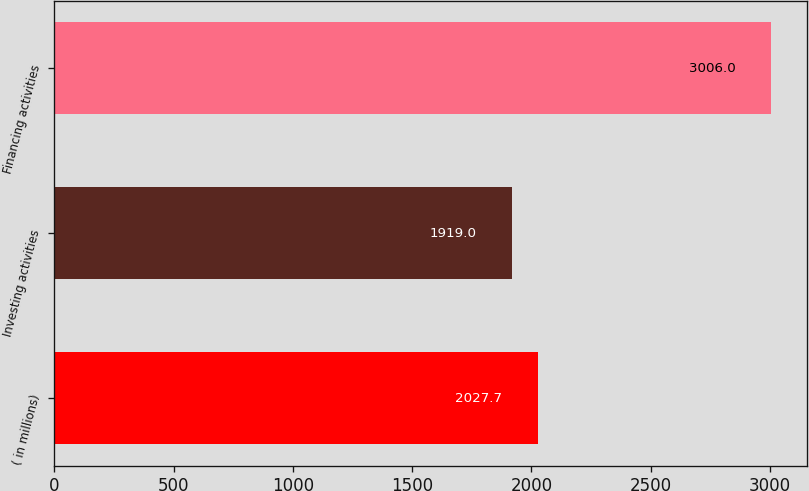Convert chart to OTSL. <chart><loc_0><loc_0><loc_500><loc_500><bar_chart><fcel>( in millions)<fcel>Investing activities<fcel>Financing activities<nl><fcel>2027.7<fcel>1919<fcel>3006<nl></chart> 